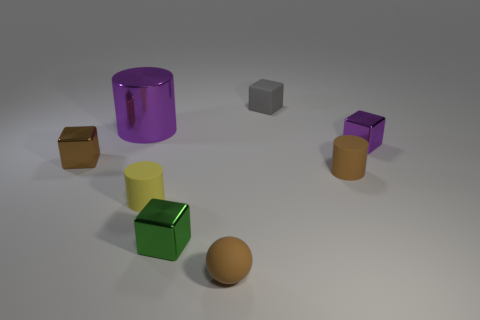Subtract all tiny brown cylinders. How many cylinders are left? 2 Add 2 big blue cylinders. How many objects exist? 10 Subtract all purple cylinders. How many cylinders are left? 2 Subtract 1 cylinders. How many cylinders are left? 2 Subtract all green cylinders. How many green blocks are left? 1 Subtract all small brown matte things. Subtract all brown cubes. How many objects are left? 5 Add 1 small matte things. How many small matte things are left? 5 Add 2 yellow shiny objects. How many yellow shiny objects exist? 2 Subtract 0 red blocks. How many objects are left? 8 Subtract all spheres. How many objects are left? 7 